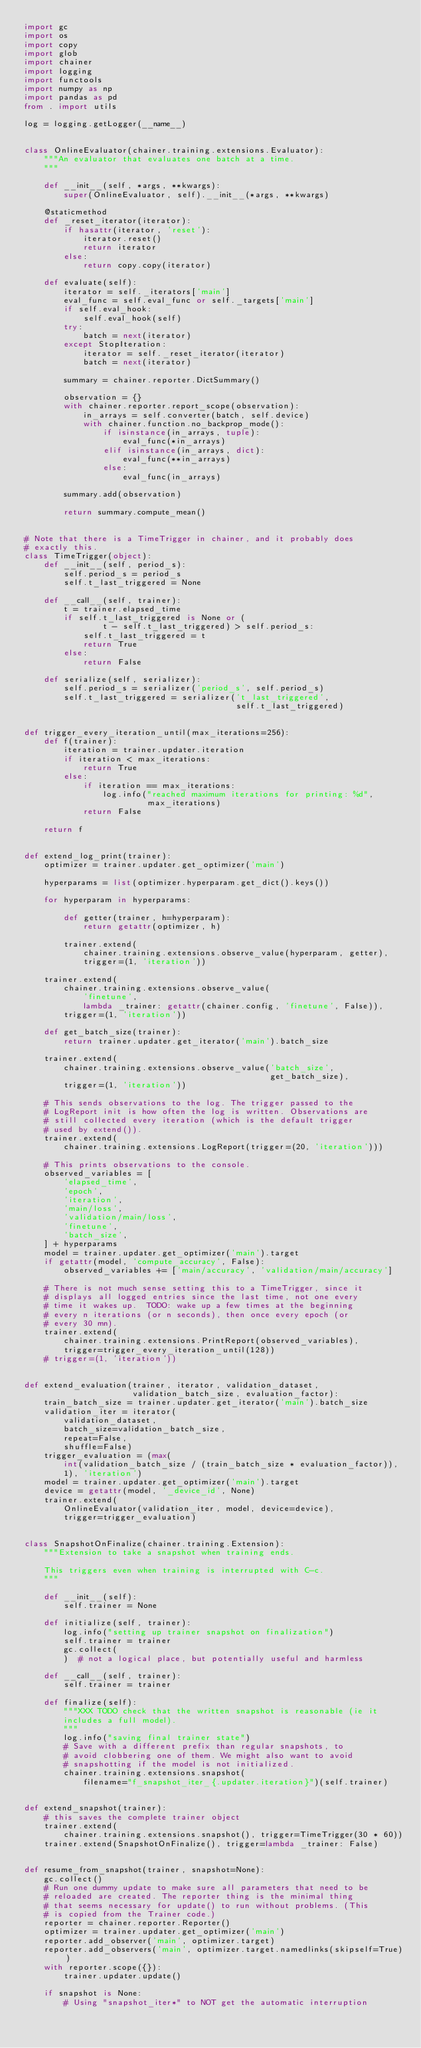Convert code to text. <code><loc_0><loc_0><loc_500><loc_500><_Python_>import gc
import os
import copy
import glob
import chainer
import logging
import functools
import numpy as np
import pandas as pd
from . import utils

log = logging.getLogger(__name__)


class OnlineEvaluator(chainer.training.extensions.Evaluator):
    """An evaluator that evaluates one batch at a time.
    """

    def __init__(self, *args, **kwargs):
        super(OnlineEvaluator, self).__init__(*args, **kwargs)

    @staticmethod
    def _reset_iterator(iterator):
        if hasattr(iterator, 'reset'):
            iterator.reset()
            return iterator
        else:
            return copy.copy(iterator)

    def evaluate(self):
        iterator = self._iterators['main']
        eval_func = self.eval_func or self._targets['main']
        if self.eval_hook:
            self.eval_hook(self)
        try:
            batch = next(iterator)
        except StopIteration:
            iterator = self._reset_iterator(iterator)
            batch = next(iterator)

        summary = chainer.reporter.DictSummary()

        observation = {}
        with chainer.reporter.report_scope(observation):
            in_arrays = self.converter(batch, self.device)
            with chainer.function.no_backprop_mode():
                if isinstance(in_arrays, tuple):
                    eval_func(*in_arrays)
                elif isinstance(in_arrays, dict):
                    eval_func(**in_arrays)
                else:
                    eval_func(in_arrays)

        summary.add(observation)

        return summary.compute_mean()


# Note that there is a TimeTrigger in chainer, and it probably does
# exactly this.
class TimeTrigger(object):
    def __init__(self, period_s):
        self.period_s = period_s
        self.t_last_triggered = None

    def __call__(self, trainer):
        t = trainer.elapsed_time
        if self.t_last_triggered is None or (
                t - self.t_last_triggered) > self.period_s:
            self.t_last_triggered = t
            return True
        else:
            return False

    def serialize(self, serializer):
        self.period_s = serializer('period_s', self.period_s)
        self.t_last_triggered = serializer('t_last_triggered',
                                           self.t_last_triggered)


def trigger_every_iteration_until(max_iterations=256):
    def f(trainer):
        iteration = trainer.updater.iteration
        if iteration < max_iterations:
            return True
        else:
            if iteration == max_iterations:
                log.info("reached maximum iterations for printing: %d",
                         max_iterations)
            return False

    return f


def extend_log_print(trainer):
    optimizer = trainer.updater.get_optimizer('main')

    hyperparams = list(optimizer.hyperparam.get_dict().keys())

    for hyperparam in hyperparams:

        def getter(trainer, h=hyperparam):
            return getattr(optimizer, h)

        trainer.extend(
            chainer.training.extensions.observe_value(hyperparam, getter),
            trigger=(1, 'iteration'))

    trainer.extend(
        chainer.training.extensions.observe_value(
            'finetune',
            lambda _trainer: getattr(chainer.config, 'finetune', False)),
        trigger=(1, 'iteration'))

    def get_batch_size(trainer):
        return trainer.updater.get_iterator('main').batch_size

    trainer.extend(
        chainer.training.extensions.observe_value('batch_size',
                                                  get_batch_size),
        trigger=(1, 'iteration'))

    # This sends observations to the log. The trigger passed to the
    # LogReport init is how often the log is written. Observations are
    # still collected every iteration (which is the default trigger
    # used by extend()).
    trainer.extend(
        chainer.training.extensions.LogReport(trigger=(20, 'iteration')))

    # This prints observations to the console.
    observed_variables = [
        'elapsed_time',
        'epoch',
        'iteration',
        'main/loss',
        'validation/main/loss',
        'finetune',
        'batch_size',
    ] + hyperparams
    model = trainer.updater.get_optimizer('main').target
    if getattr(model, 'compute_accuracy', False):
        observed_variables += ['main/accuracy', 'validation/main/accuracy']

    # There is not much sense setting this to a TimeTrigger, since it
    # displays all logged entries since the last time, not one every
    # time it wakes up.  TODO: wake up a few times at the beginning
    # every n iterations (or n seconds), then once every epoch (or
    # every 30 mn).
    trainer.extend(
        chainer.training.extensions.PrintReport(observed_variables),
        trigger=trigger_every_iteration_until(128))
    # trigger=(1, 'iteration'))


def extend_evaluation(trainer, iterator, validation_dataset,
                      validation_batch_size, evaluation_factor):
    train_batch_size = trainer.updater.get_iterator('main').batch_size
    validation_iter = iterator(
        validation_dataset,
        batch_size=validation_batch_size,
        repeat=False,
        shuffle=False)
    trigger_evaluation = (max(
        int(validation_batch_size / (train_batch_size * evaluation_factor)),
        1), 'iteration')
    model = trainer.updater.get_optimizer('main').target
    device = getattr(model, '_device_id', None)
    trainer.extend(
        OnlineEvaluator(validation_iter, model, device=device),
        trigger=trigger_evaluation)


class SnapshotOnFinalize(chainer.training.Extension):
    """Extension to take a snapshot when training ends.

    This triggers even when training is interrupted with C-c.
    """

    def __init__(self):
        self.trainer = None

    def initialize(self, trainer):
        log.info("setting up trainer snapshot on finalization")
        self.trainer = trainer
        gc.collect(
        )  # not a logical place, but potentially useful and harmless

    def __call__(self, trainer):
        self.trainer = trainer

    def finalize(self):
        """XXX TODO check that the written snapshot is reasonable (ie it
        includes a full model).
        """
        log.info("saving final trainer state")
        # Save with a different prefix than regular snapshots, to
        # avoid clobbering one of them. We might also want to avoid
        # snapshotting if the model is not initialized.
        chainer.training.extensions.snapshot(
            filename="f_snapshot_iter_{.updater.iteration}")(self.trainer)


def extend_snapshot(trainer):
    # this saves the complete trainer object
    trainer.extend(
        chainer.training.extensions.snapshot(), trigger=TimeTrigger(30 * 60))
    trainer.extend(SnapshotOnFinalize(), trigger=lambda _trainer: False)


def resume_from_snapshot(trainer, snapshot=None):
    gc.collect()
    # Run one dummy update to make sure all parameters that need to be
    # reloaded are created. The reporter thing is the minimal thing
    # that seems necessary for update() to run without problems. (This
    # is copied from the Trainer code.)
    reporter = chainer.reporter.Reporter()
    optimizer = trainer.updater.get_optimizer('main')
    reporter.add_observer('main', optimizer.target)
    reporter.add_observers('main', optimizer.target.namedlinks(skipself=True))
    with reporter.scope({}):
        trainer.updater.update()

    if snapshot is None:
        # Using "snapshot_iter*" to NOT get the automatic interruption</code> 